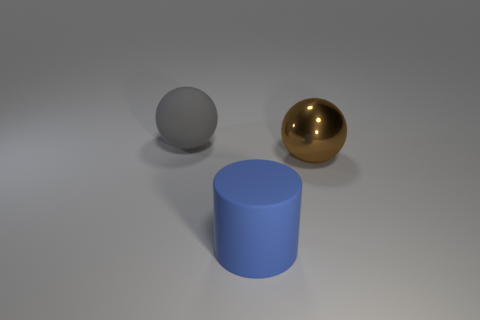Is there anything else that is the same material as the brown object?
Offer a terse response. No. There is a large sphere behind the big brown ball; how many big rubber balls are behind it?
Provide a succinct answer. 0. There is a rubber thing that is right of the matte ball; what is its shape?
Your response must be concise. Cylinder. What is the material of the large ball that is right of the large rubber thing that is behind the big object on the right side of the matte cylinder?
Provide a short and direct response. Metal. How many other objects are the same size as the brown metal sphere?
Your response must be concise. 2. There is another thing that is the same shape as the large gray object; what is it made of?
Your response must be concise. Metal. What color is the shiny sphere?
Keep it short and to the point. Brown. There is a ball that is right of the large object behind the metal sphere; what color is it?
Provide a short and direct response. Brown. There is a big blue thing in front of the large gray rubber thing behind the large brown metal ball; what number of brown metallic things are behind it?
Provide a short and direct response. 1. Are there any objects to the right of the big blue matte cylinder?
Offer a very short reply. Yes. 